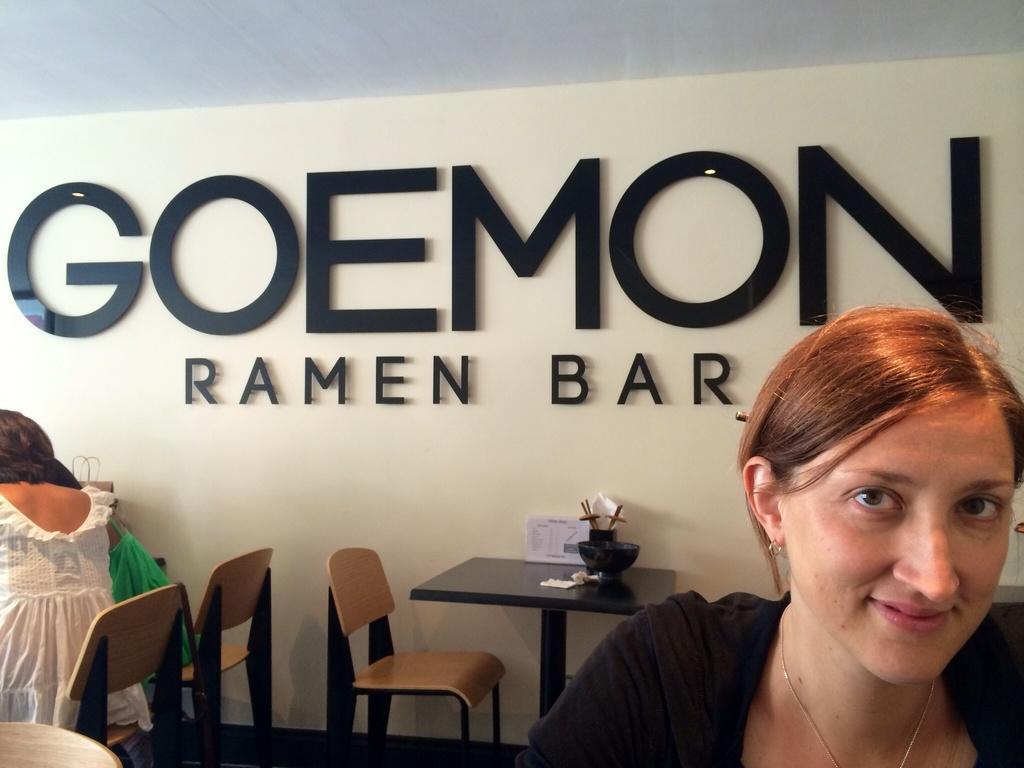In one or two sentences, can you explain what this image depicts? A woman is smiling on the right side. A woman and a girl is sitting on the left side. There are table, chairs in this room. On the table there is a bowl, box, papers and some item. In the background there is a wall with name board. 